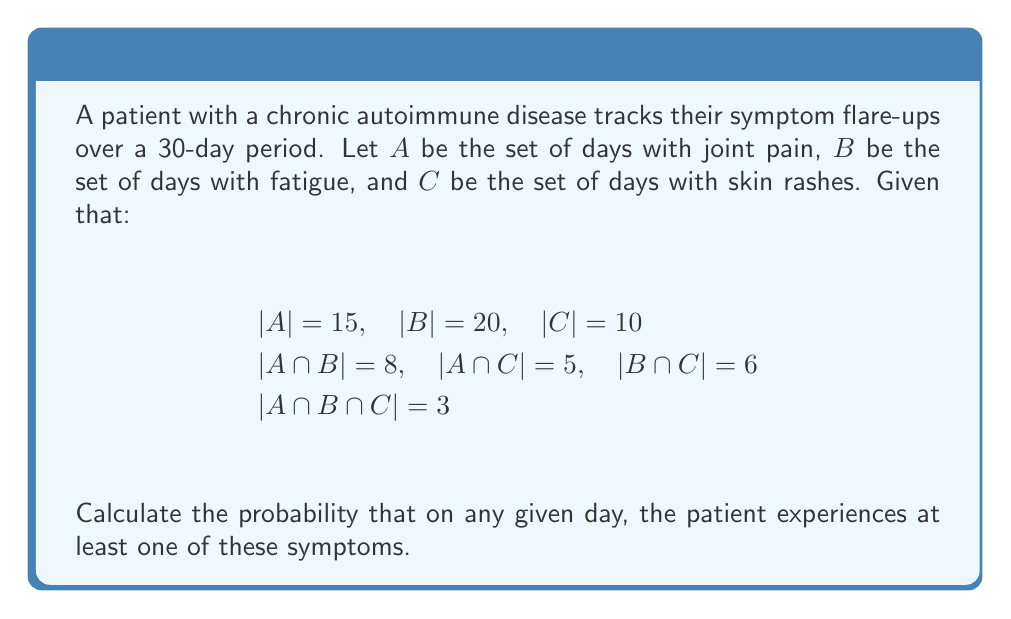Help me with this question. To solve this problem, we'll use the Inclusion-Exclusion Principle from set theory.

1) First, let's define the universal set U as the total number of days: $|U| = 30$

2) We need to find $|A \cup B \cup C|$, which represents the number of days with at least one symptom.

3) The Inclusion-Exclusion Principle states:

   $$|A \cup B \cup C| = |A| + |B| + |C| - |A \cap B| - |A \cap C| - |B \cap C| + |A \cap B \cap C|$$

4) Substituting the given values:

   $$|A \cup B \cup C| = 15 + 20 + 10 - 8 - 5 - 6 + 3 = 29$$

5) This means that out of 30 days, 29 days had at least one symptom.

6) To calculate the probability, we divide the number of favorable outcomes by the total number of possible outcomes:

   $$P(\text{at least one symptom}) = \frac{|A \cup B \cup C|}{|U|} = \frac{29}{30}$$
Answer: The probability that the patient experiences at least one symptom on any given day is $\frac{29}{30}$ or approximately 0.9667 (96.67%). 